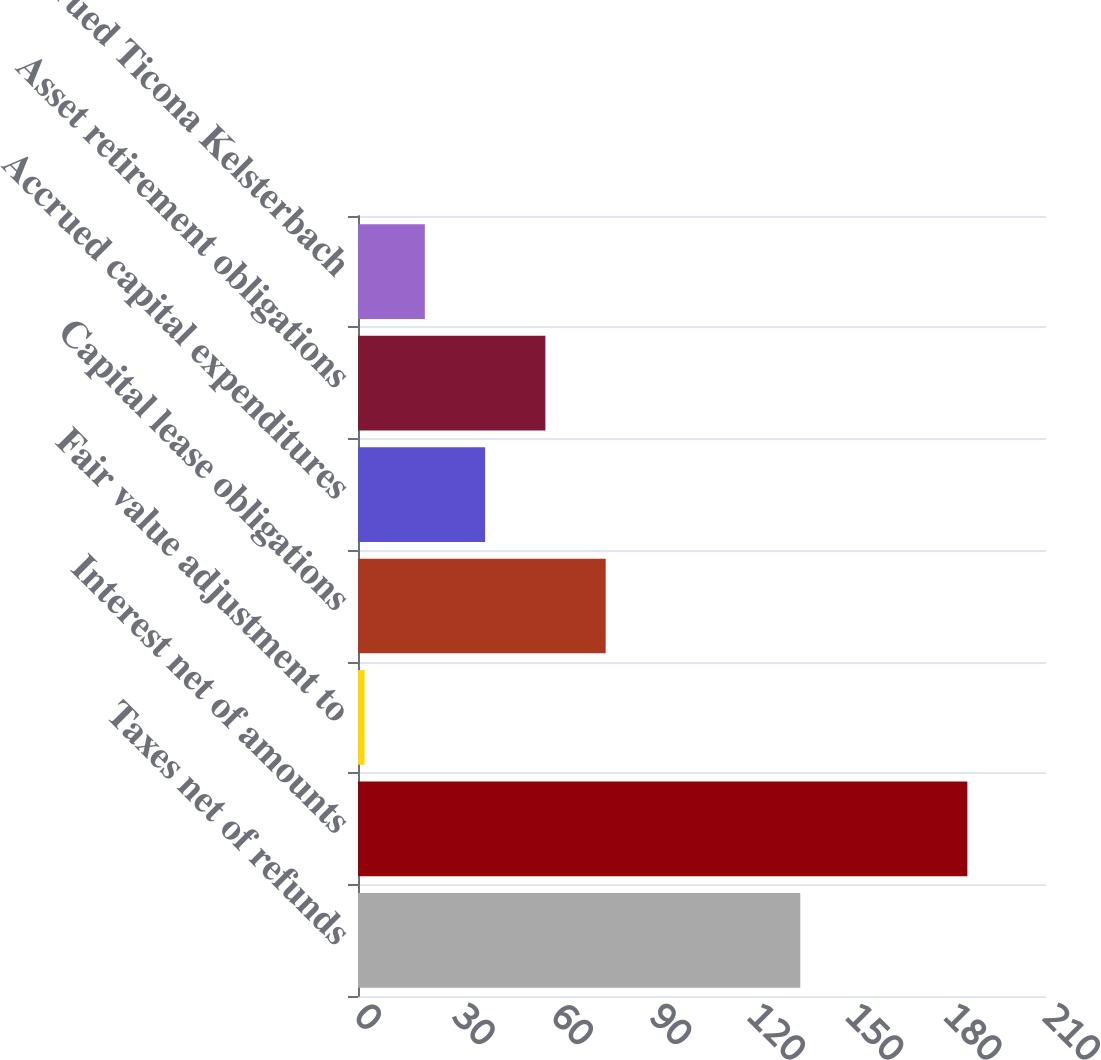Convert chart. <chart><loc_0><loc_0><loc_500><loc_500><bar_chart><fcel>Taxes net of refunds<fcel>Interest net of amounts<fcel>Fair value adjustment to<fcel>Capital lease obligations<fcel>Accrued capital expenditures<fcel>Asset retirement obligations<fcel>Accrued Ticona Kelsterbach<nl><fcel>135<fcel>186<fcel>2<fcel>75.6<fcel>38.8<fcel>57.2<fcel>20.4<nl></chart> 